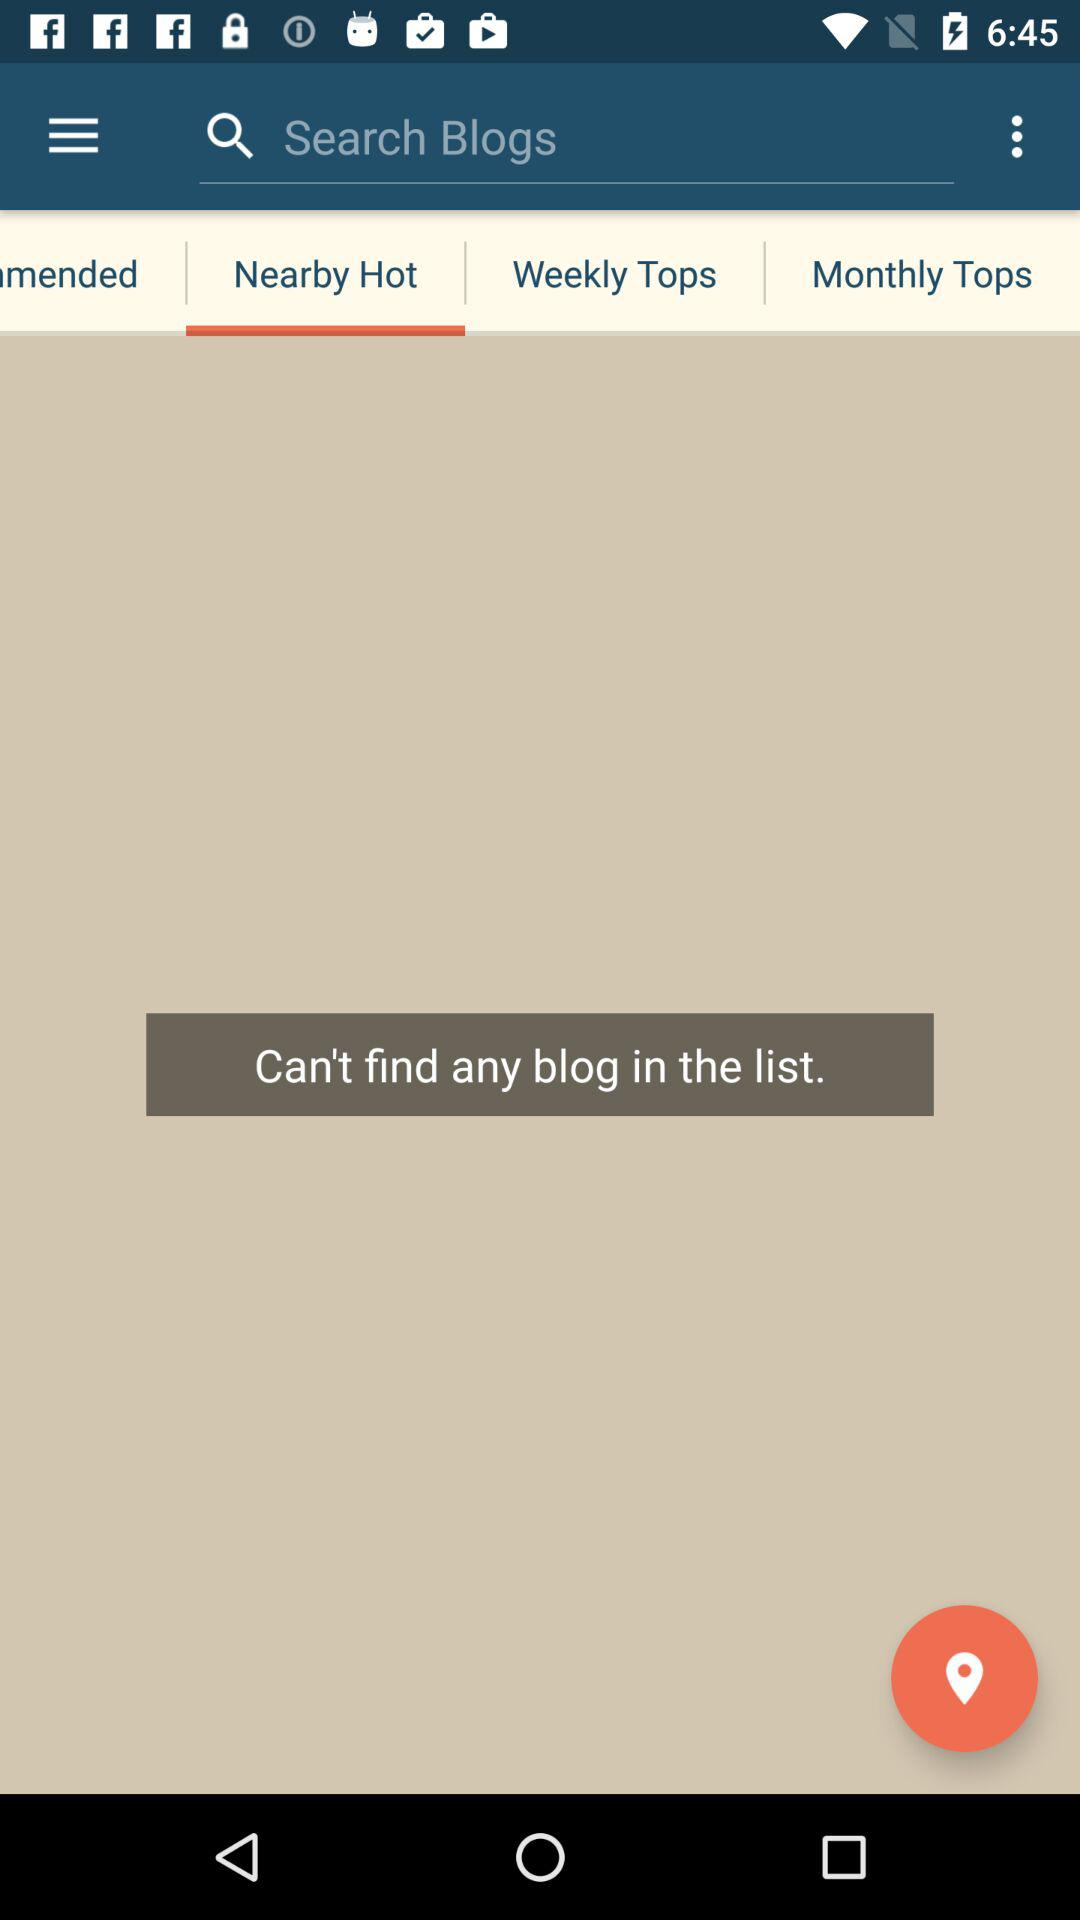Which tab is selected? The selected tab is "Nearby Hot". 